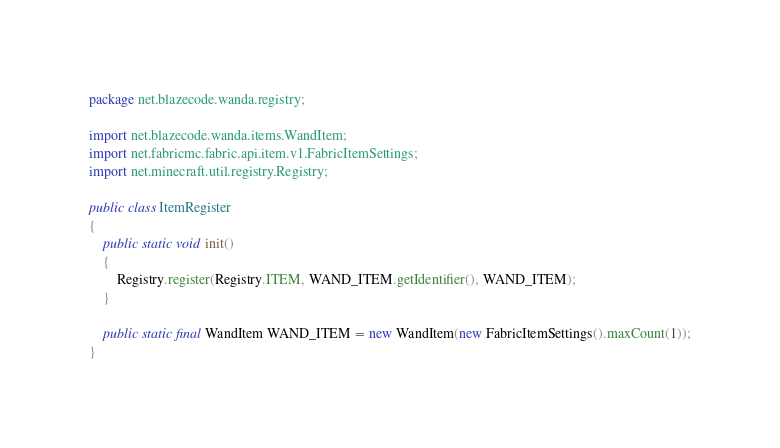Convert code to text. <code><loc_0><loc_0><loc_500><loc_500><_Java_>package net.blazecode.wanda.registry;

import net.blazecode.wanda.items.WandItem;
import net.fabricmc.fabric.api.item.v1.FabricItemSettings;
import net.minecraft.util.registry.Registry;

public class ItemRegister
{
    public static void init()
    {
        Registry.register(Registry.ITEM, WAND_ITEM.getIdentifier(), WAND_ITEM);
    }

    public static final WandItem WAND_ITEM = new WandItem(new FabricItemSettings().maxCount(1));
}
</code> 